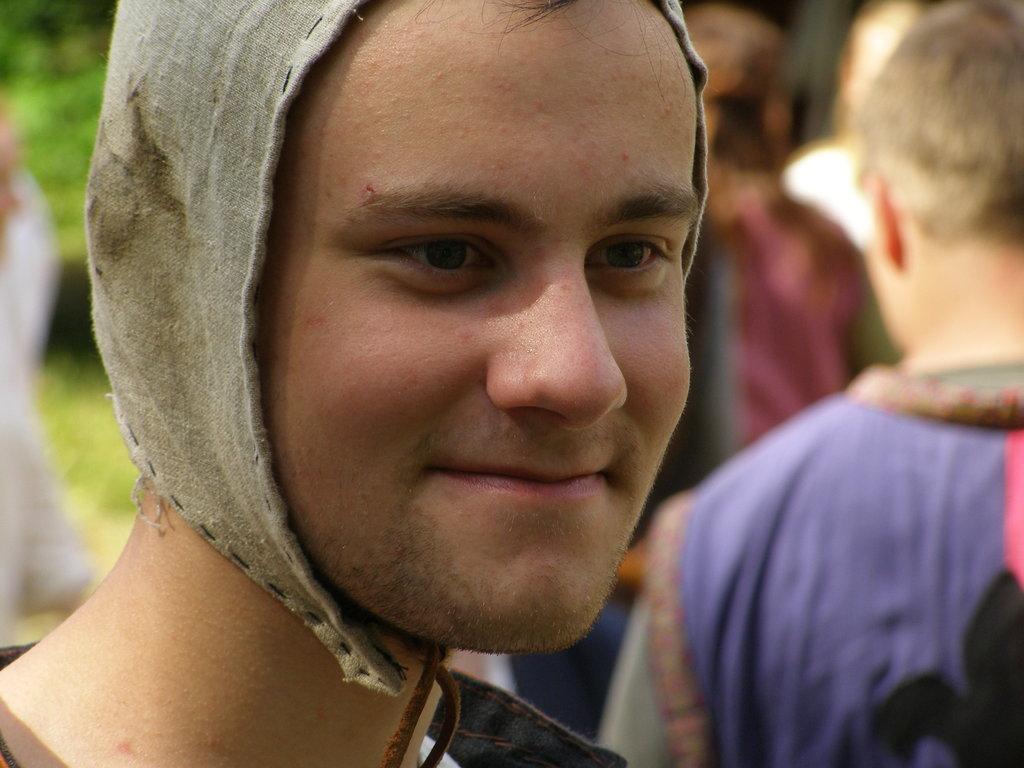Could you give a brief overview of what you see in this image? In this image we can see a person and he is smiling. In the background we can see people and greenery. 